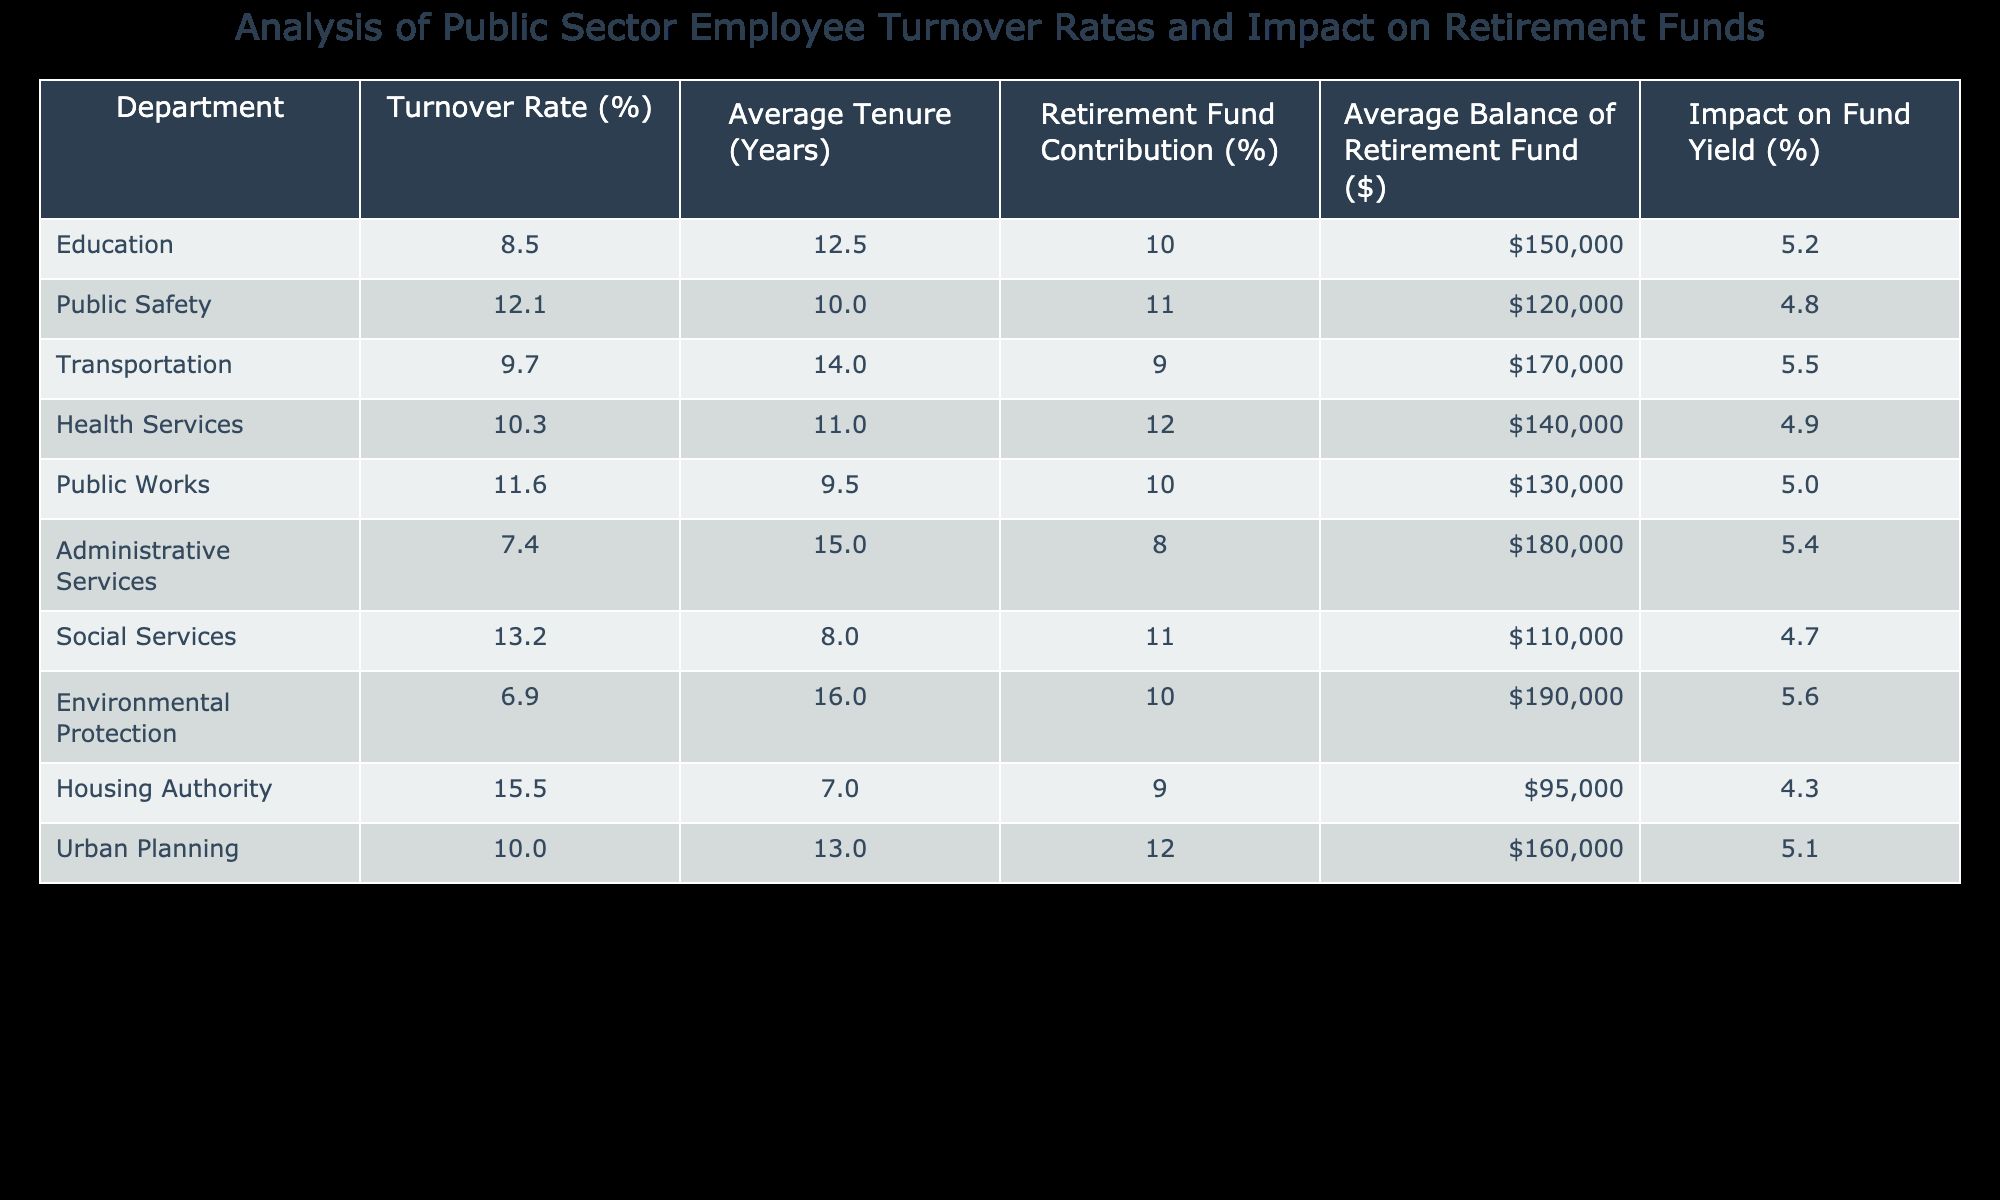What is the turnover rate for the Housing Authority? The turnover rate for the Housing Authority can be found in the table under the "Turnover Rate (%)" column. It shows a value of 15.5%.
Answer: 15.5% Which department has the highest average balance in the retirement fund? By looking under the "Average Balance of Retirement Fund ($)" column, the Education department with a balance of $150,000 has the highest value compared to others.
Answer: $150,000 What is the difference between the turnover rates of Education and Public Safety? The turnover rate for Education is 8.5% and for Public Safety it is 12.1%. The difference is calculated by subtracting 8.5% from 12.1%, which equals 3.6%.
Answer: 3.6% Is the average tenure for the Social Services department higher than 10 years? The average tenure for Social Services is 8 years, which is less than 10 years. Therefore, the answer is no.
Answer: No What is the average impact on fund yield for departments with a turnover rate greater than 10%? We take the departments with a turnover rate greater than 10%, which are Public Safety, Public Works, Social Services, and Housing Authority. Their impact percentages are 4.8, 5.0, 4.7, and 4.3 respectively. The average of these values is (4.8 + 5.0 + 4.7 + 4.3) / 4 = 4.7%.
Answer: 4.7% Which department has the lowest retirement fund contribution percentage? The retirement fund contribution percentage is lowest for Administrative Services at 8%. It can be found in the "Retirement Fund Contribution (%)" column for that department.
Answer: 8% Does the Environmental Protection department have a higher average tenure than the Transportation department? The average tenure for Environmental Protection is 16 years, while for Transportation it is 14 years. Since 16 is greater than 14, the answer is yes.
Answer: Yes What is the average turnover rate for departments that contribute 11% or more to the retirement fund? The departments contributing 11% or more are Public Safety (12.1%), Health Services (12%), and Social Services (11%). To calculate the average, we add 12.1 + 12 + 11 = 35.1 and divide by 3, resulting in an average turnover rate of 11.7%.
Answer: 11.7% 